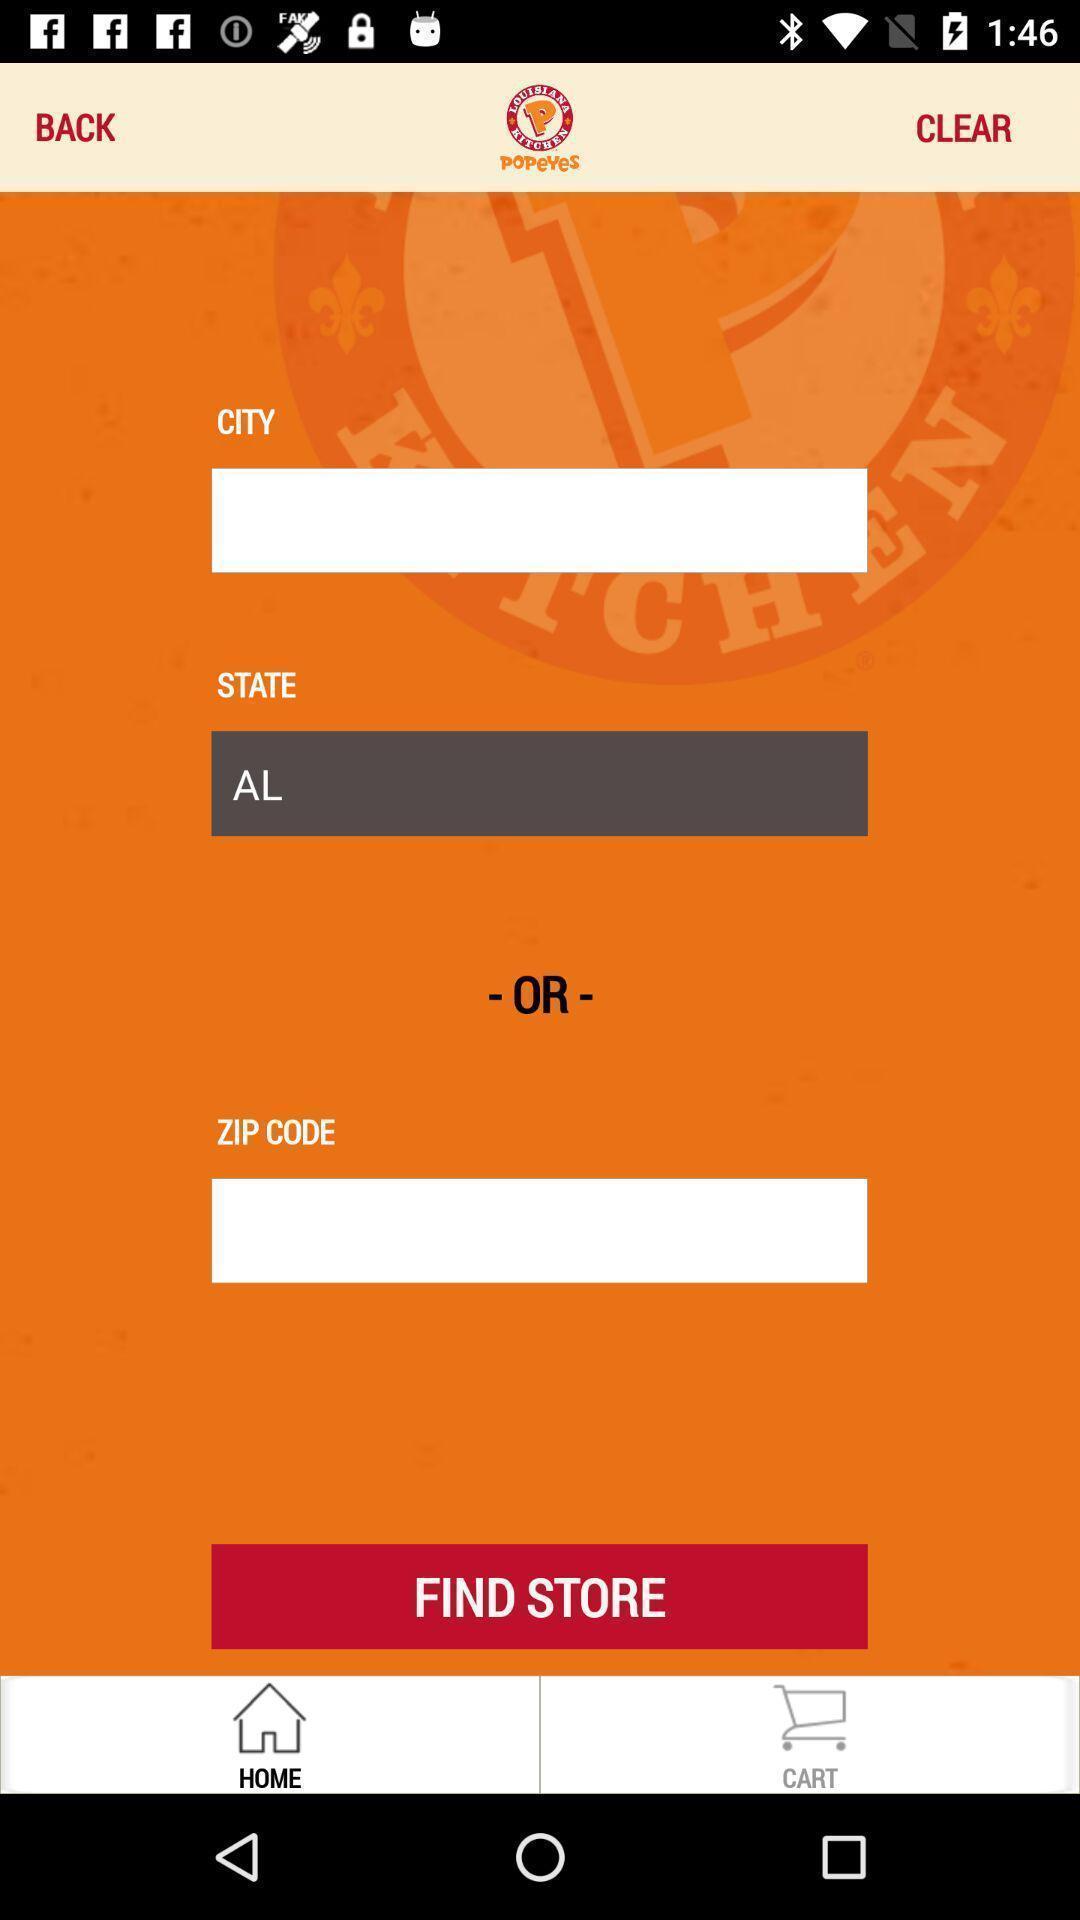Give me a narrative description of this picture. Page for finding store of a shopping app. 